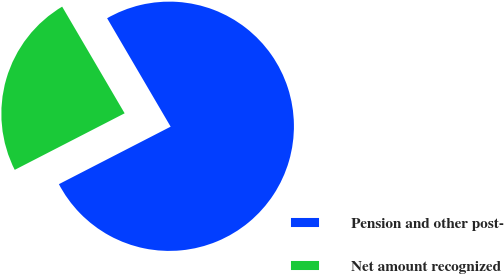Convert chart. <chart><loc_0><loc_0><loc_500><loc_500><pie_chart><fcel>Pension and other post-<fcel>Net amount recognized<nl><fcel>75.87%<fcel>24.13%<nl></chart> 